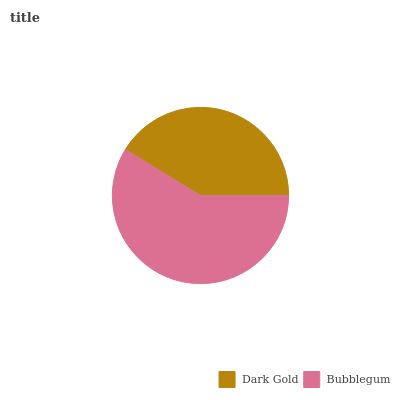Is Dark Gold the minimum?
Answer yes or no. Yes. Is Bubblegum the maximum?
Answer yes or no. Yes. Is Bubblegum the minimum?
Answer yes or no. No. Is Bubblegum greater than Dark Gold?
Answer yes or no. Yes. Is Dark Gold less than Bubblegum?
Answer yes or no. Yes. Is Dark Gold greater than Bubblegum?
Answer yes or no. No. Is Bubblegum less than Dark Gold?
Answer yes or no. No. Is Bubblegum the high median?
Answer yes or no. Yes. Is Dark Gold the low median?
Answer yes or no. Yes. Is Dark Gold the high median?
Answer yes or no. No. Is Bubblegum the low median?
Answer yes or no. No. 